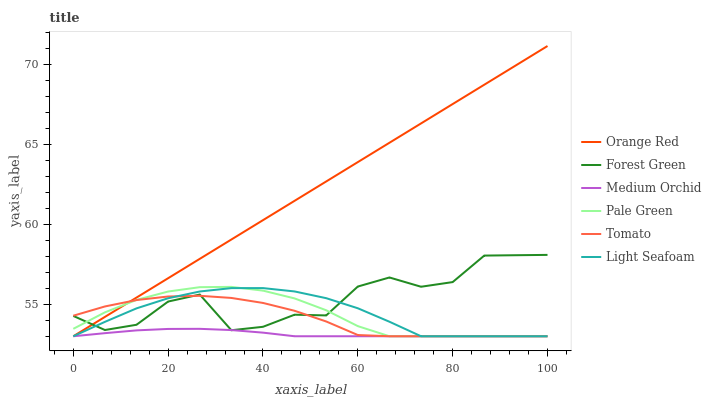Does Medium Orchid have the minimum area under the curve?
Answer yes or no. Yes. Does Orange Red have the maximum area under the curve?
Answer yes or no. Yes. Does Forest Green have the minimum area under the curve?
Answer yes or no. No. Does Forest Green have the maximum area under the curve?
Answer yes or no. No. Is Orange Red the smoothest?
Answer yes or no. Yes. Is Forest Green the roughest?
Answer yes or no. Yes. Is Medium Orchid the smoothest?
Answer yes or no. No. Is Medium Orchid the roughest?
Answer yes or no. No. Does Tomato have the lowest value?
Answer yes or no. Yes. Does Forest Green have the lowest value?
Answer yes or no. No. Does Orange Red have the highest value?
Answer yes or no. Yes. Does Forest Green have the highest value?
Answer yes or no. No. Does Medium Orchid intersect Light Seafoam?
Answer yes or no. Yes. Is Medium Orchid less than Light Seafoam?
Answer yes or no. No. Is Medium Orchid greater than Light Seafoam?
Answer yes or no. No. 